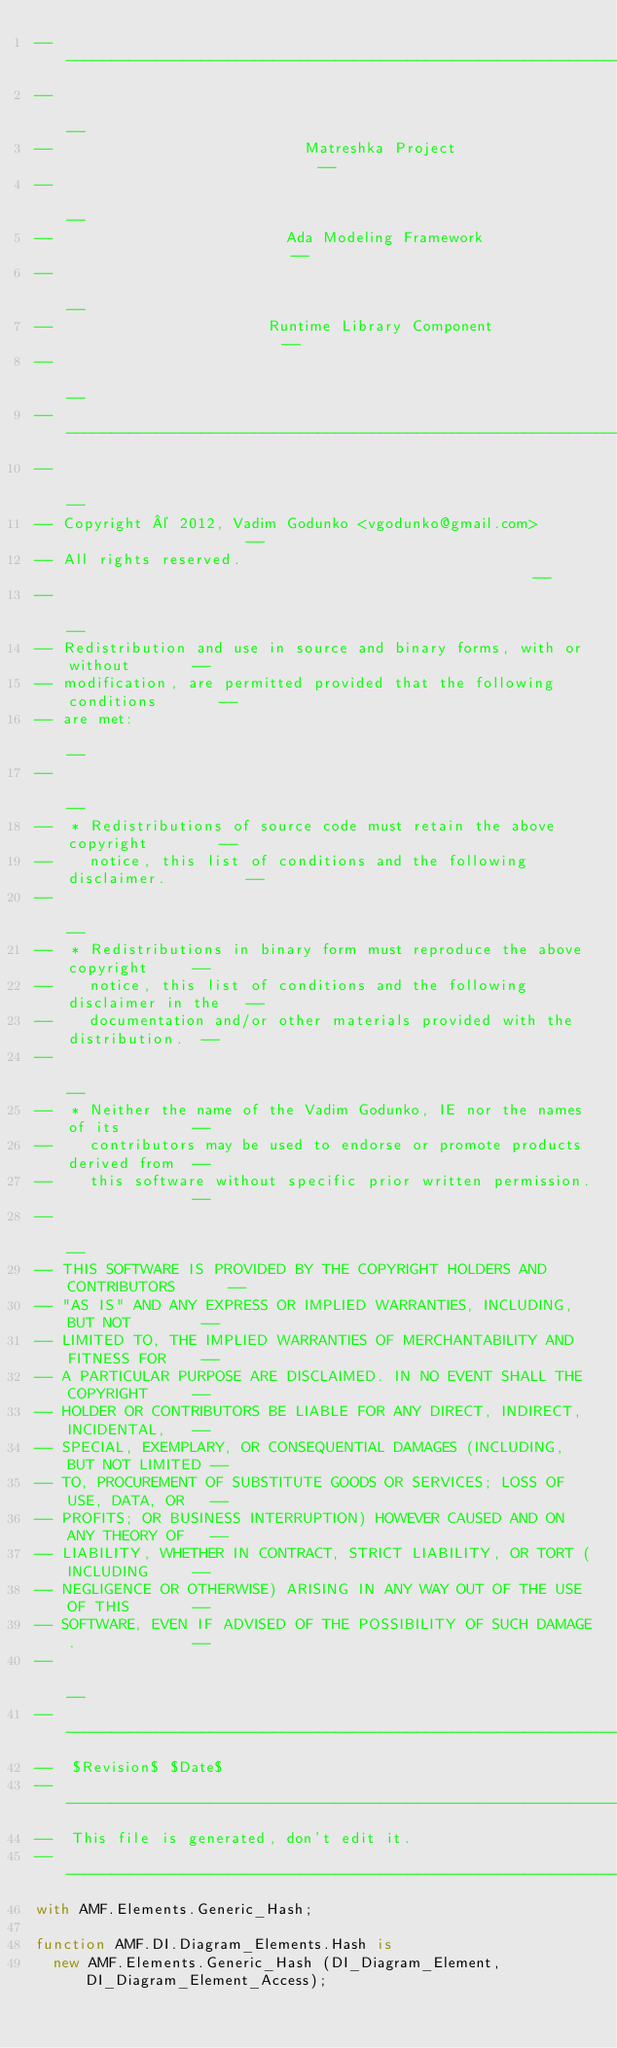<code> <loc_0><loc_0><loc_500><loc_500><_Ada_>------------------------------------------------------------------------------
--                                                                          --
--                            Matreshka Project                             --
--                                                                          --
--                          Ada Modeling Framework                          --
--                                                                          --
--                        Runtime Library Component                         --
--                                                                          --
------------------------------------------------------------------------------
--                                                                          --
-- Copyright © 2012, Vadim Godunko <vgodunko@gmail.com>                     --
-- All rights reserved.                                                     --
--                                                                          --
-- Redistribution and use in source and binary forms, with or without       --
-- modification, are permitted provided that the following conditions       --
-- are met:                                                                 --
--                                                                          --
--  * Redistributions of source code must retain the above copyright        --
--    notice, this list of conditions and the following disclaimer.         --
--                                                                          --
--  * Redistributions in binary form must reproduce the above copyright     --
--    notice, this list of conditions and the following disclaimer in the   --
--    documentation and/or other materials provided with the distribution.  --
--                                                                          --
--  * Neither the name of the Vadim Godunko, IE nor the names of its        --
--    contributors may be used to endorse or promote products derived from  --
--    this software without specific prior written permission.              --
--                                                                          --
-- THIS SOFTWARE IS PROVIDED BY THE COPYRIGHT HOLDERS AND CONTRIBUTORS      --
-- "AS IS" AND ANY EXPRESS OR IMPLIED WARRANTIES, INCLUDING, BUT NOT        --
-- LIMITED TO, THE IMPLIED WARRANTIES OF MERCHANTABILITY AND FITNESS FOR    --
-- A PARTICULAR PURPOSE ARE DISCLAIMED. IN NO EVENT SHALL THE COPYRIGHT     --
-- HOLDER OR CONTRIBUTORS BE LIABLE FOR ANY DIRECT, INDIRECT, INCIDENTAL,   --
-- SPECIAL, EXEMPLARY, OR CONSEQUENTIAL DAMAGES (INCLUDING, BUT NOT LIMITED --
-- TO, PROCUREMENT OF SUBSTITUTE GOODS OR SERVICES; LOSS OF USE, DATA, OR   --
-- PROFITS; OR BUSINESS INTERRUPTION) HOWEVER CAUSED AND ON ANY THEORY OF   --
-- LIABILITY, WHETHER IN CONTRACT, STRICT LIABILITY, OR TORT (INCLUDING     --
-- NEGLIGENCE OR OTHERWISE) ARISING IN ANY WAY OUT OF THE USE OF THIS       --
-- SOFTWARE, EVEN IF ADVISED OF THE POSSIBILITY OF SUCH DAMAGE.             --
--                                                                          --
------------------------------------------------------------------------------
--  $Revision$ $Date$
------------------------------------------------------------------------------
--  This file is generated, don't edit it.
------------------------------------------------------------------------------
with AMF.Elements.Generic_Hash;

function AMF.DI.Diagram_Elements.Hash is
  new AMF.Elements.Generic_Hash (DI_Diagram_Element, DI_Diagram_Element_Access);
</code> 